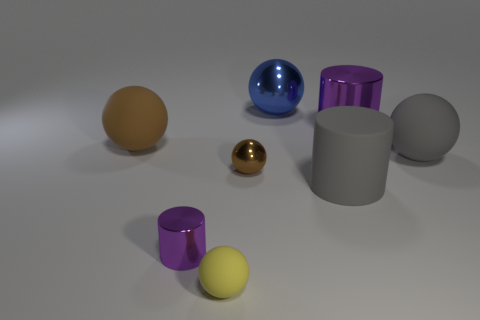Can you tell me what colors are the spheres in this image? Certainly! The spheres in the image are orange, blue, gold, and yellow. And what about the cylinders? What colors are they? The cylinders in the image are purple, silver, and gray. 